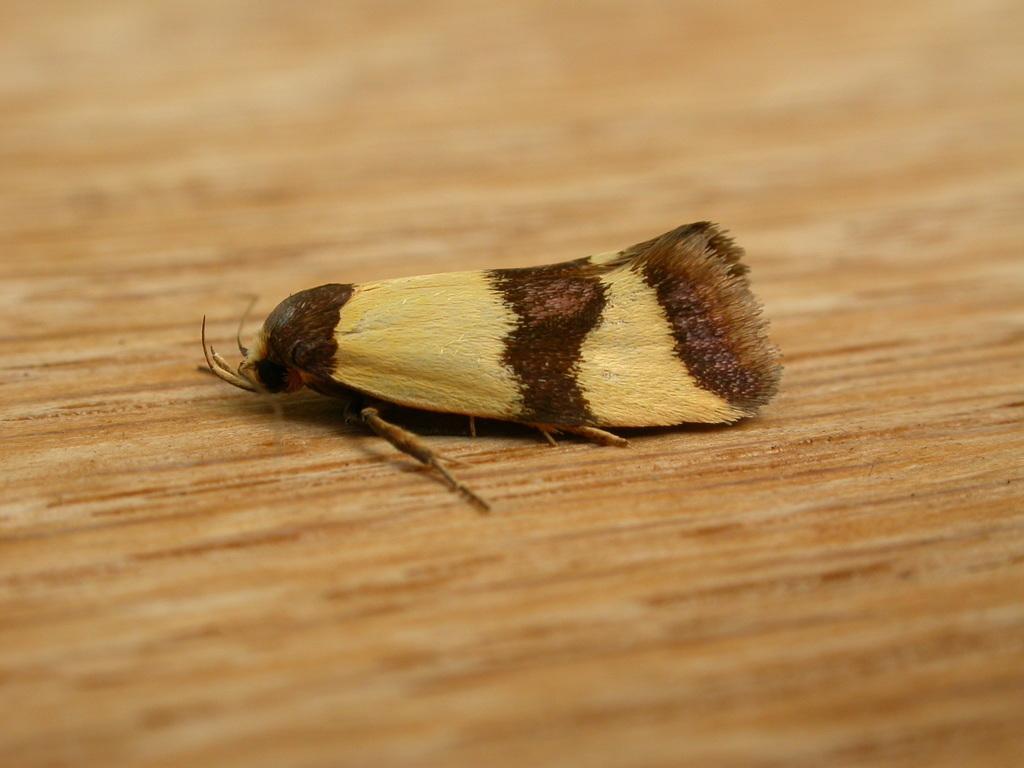In one or two sentences, can you explain what this image depicts? In this image I can see an insect in cream and brown color. The insect is on the brown color surface. 